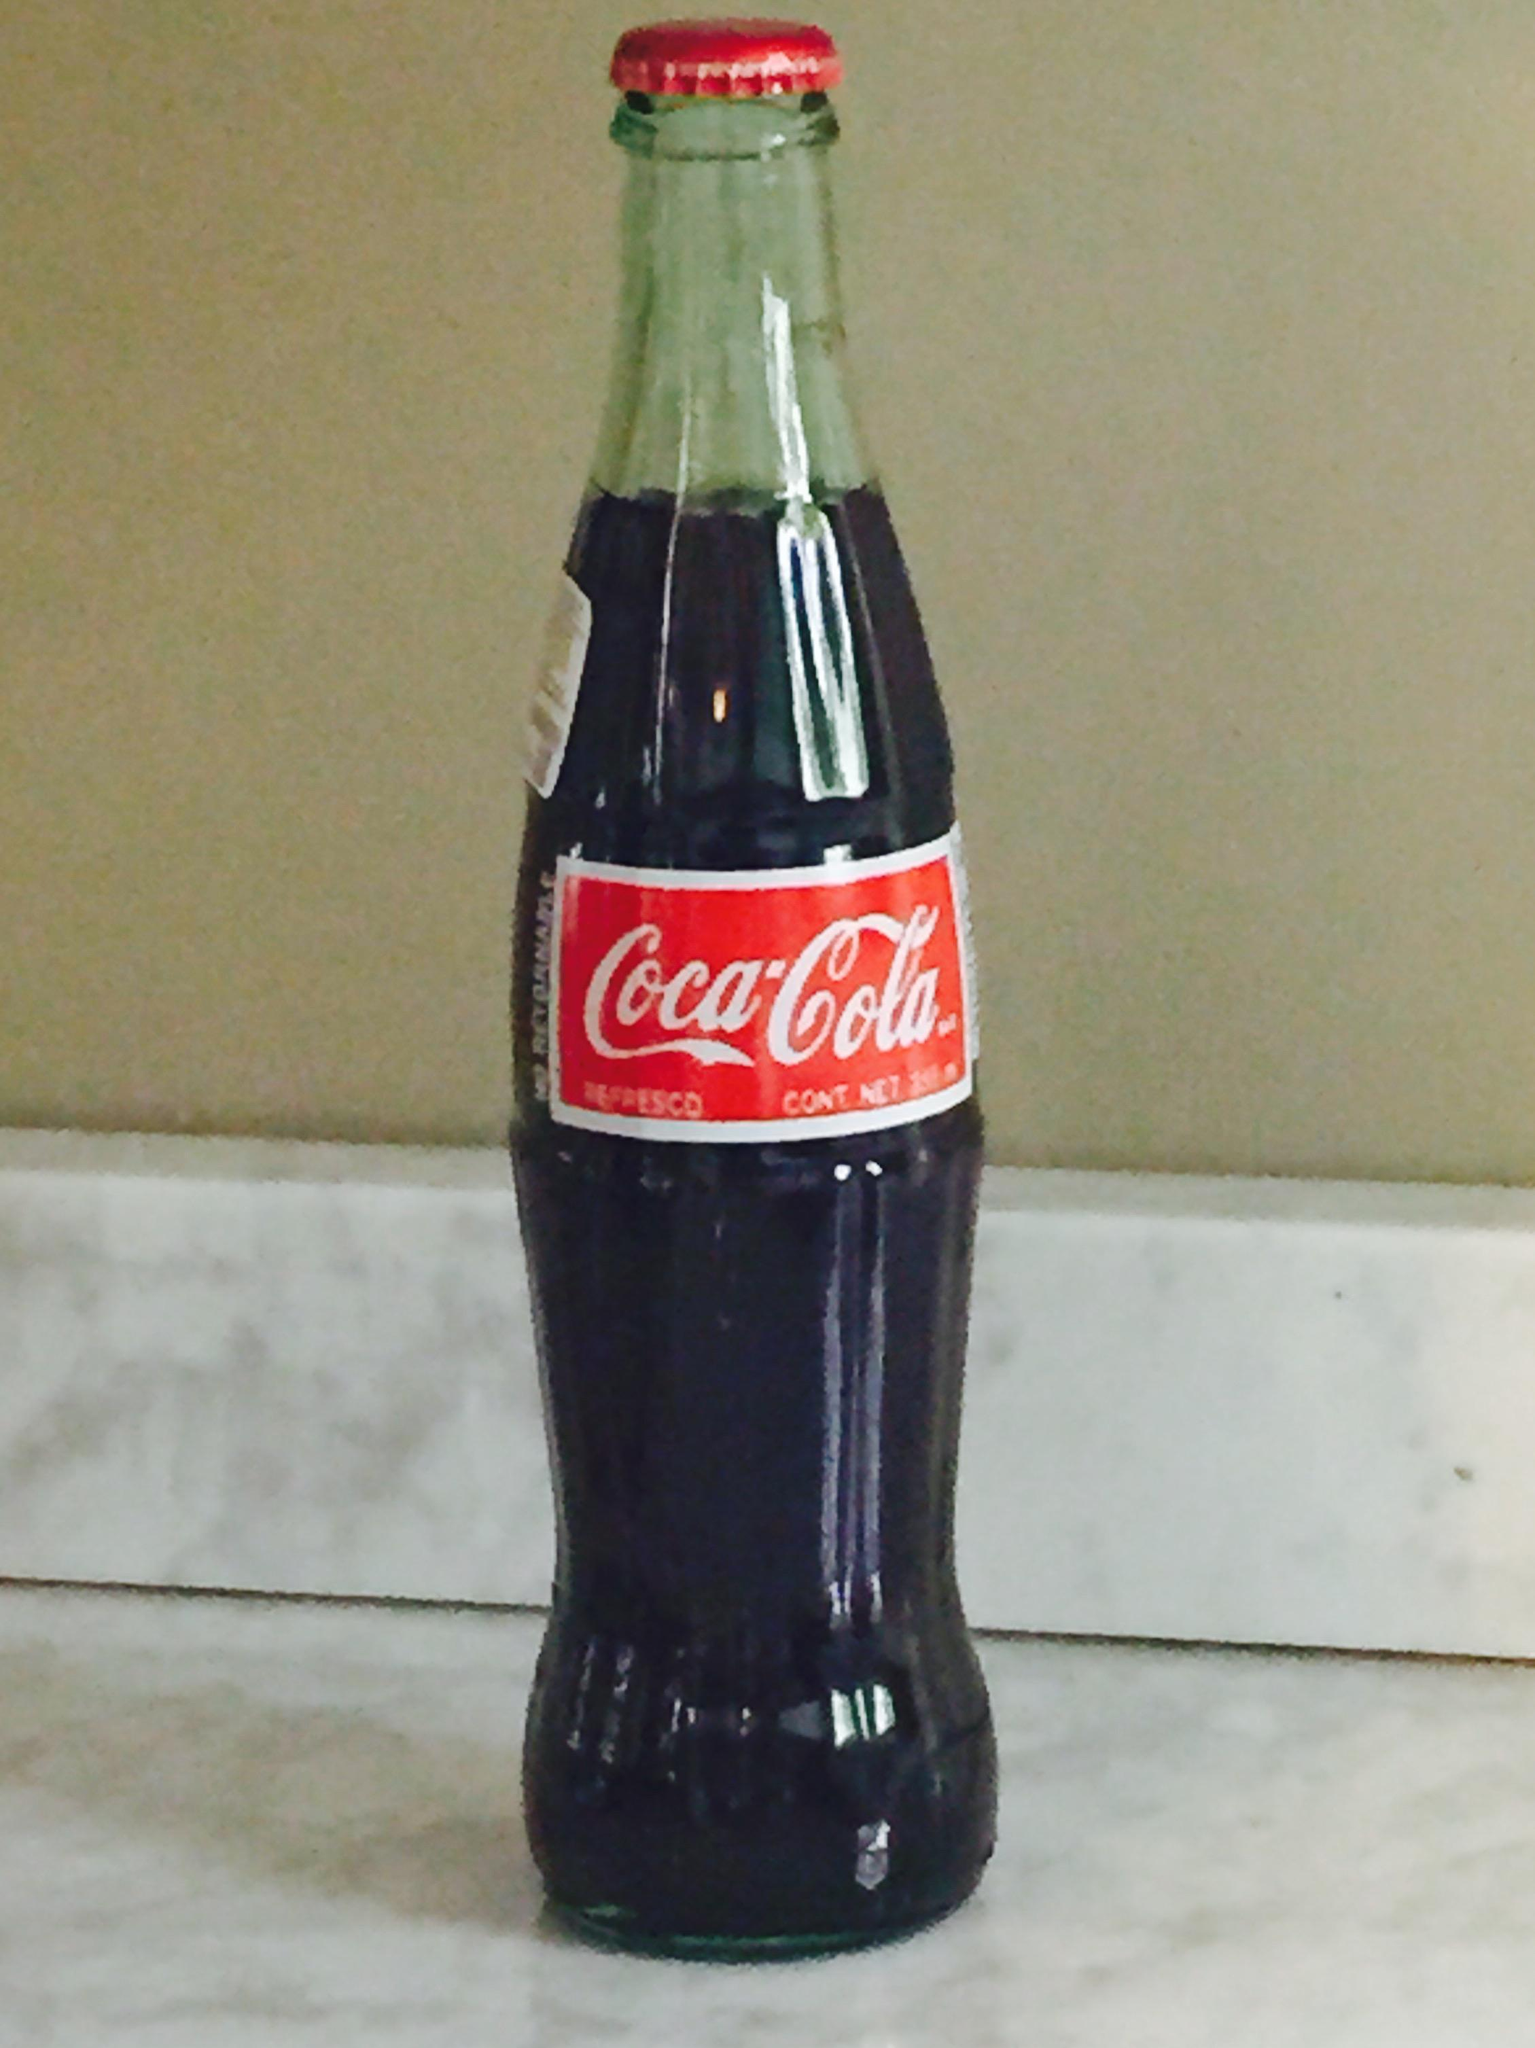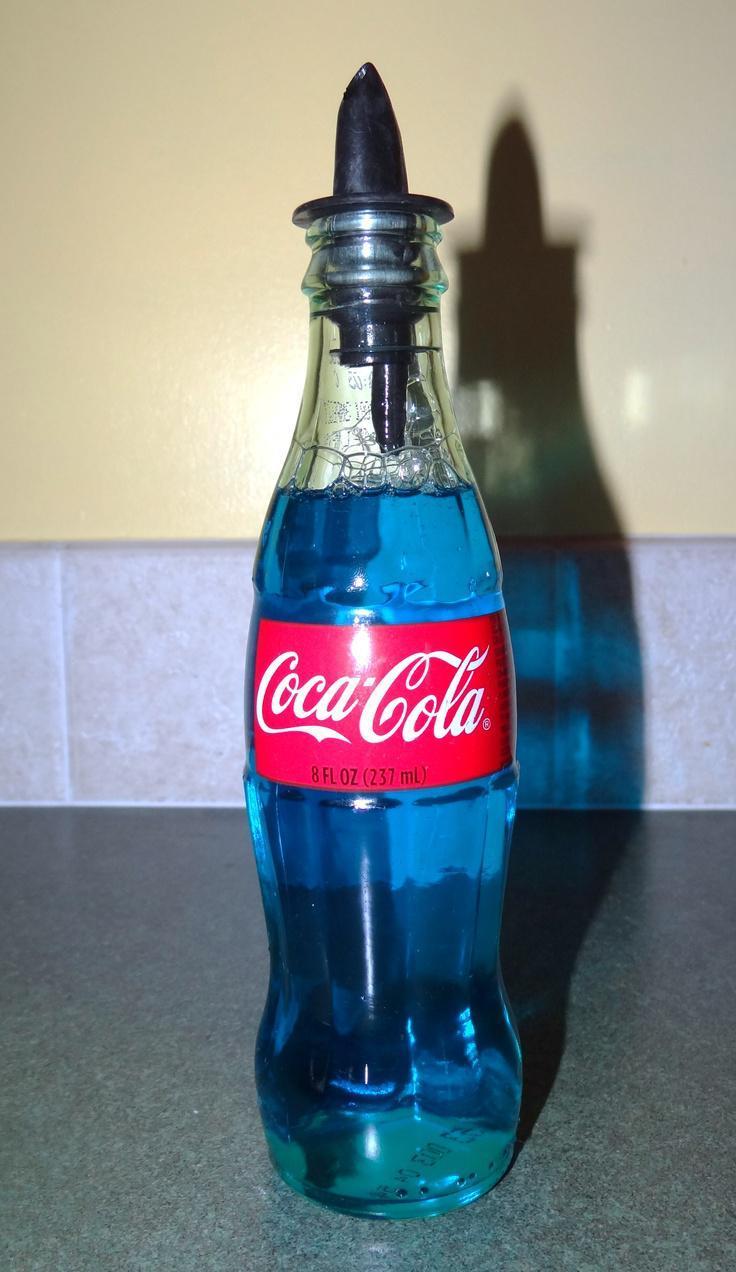The first image is the image on the left, the second image is the image on the right. Analyze the images presented: Is the assertion "One image contains several evenly spaced glass soda bottles with white lettering on red labels." valid? Answer yes or no. No. The first image is the image on the left, the second image is the image on the right. Analyze the images presented: Is the assertion "There are exactly two bottles." valid? Answer yes or no. Yes. 